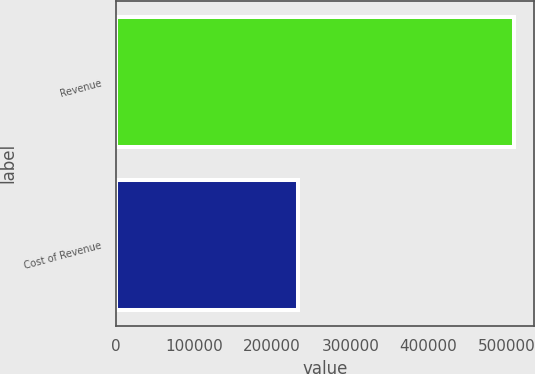<chart> <loc_0><loc_0><loc_500><loc_500><bar_chart><fcel>Revenue<fcel>Cost of Revenue<nl><fcel>509821<fcel>232868<nl></chart> 